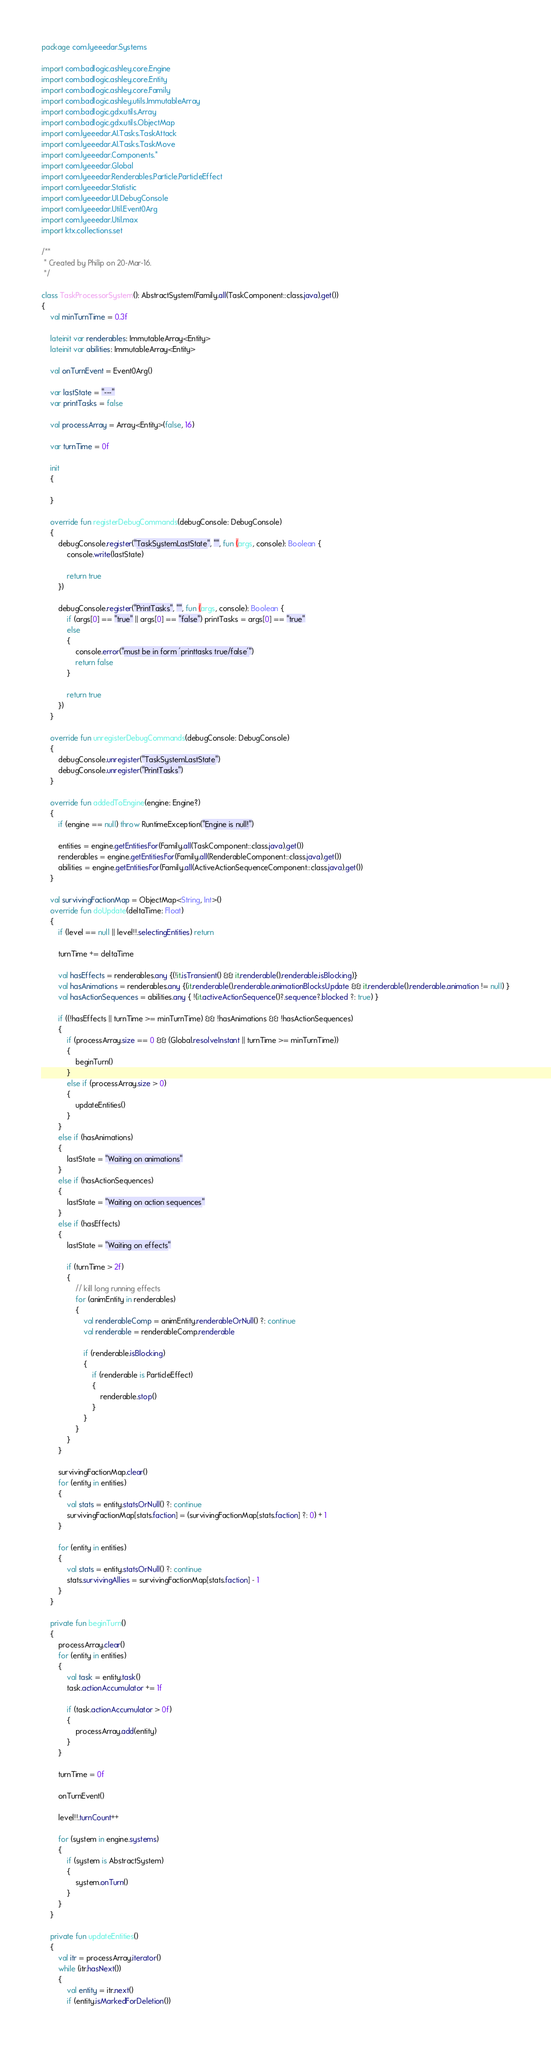<code> <loc_0><loc_0><loc_500><loc_500><_Kotlin_>package com.lyeeedar.Systems

import com.badlogic.ashley.core.Engine
import com.badlogic.ashley.core.Entity
import com.badlogic.ashley.core.Family
import com.badlogic.ashley.utils.ImmutableArray
import com.badlogic.gdx.utils.Array
import com.badlogic.gdx.utils.ObjectMap
import com.lyeeedar.AI.Tasks.TaskAttack
import com.lyeeedar.AI.Tasks.TaskMove
import com.lyeeedar.Components.*
import com.lyeeedar.Global
import com.lyeeedar.Renderables.Particle.ParticleEffect
import com.lyeeedar.Statistic
import com.lyeeedar.UI.DebugConsole
import com.lyeeedar.Util.Event0Arg
import com.lyeeedar.Util.max
import ktx.collections.set

/**
 * Created by Philip on 20-Mar-16.
 */

class TaskProcessorSystem(): AbstractSystem(Family.all(TaskComponent::class.java).get())
{
	val minTurnTime = 0.3f

	lateinit var renderables: ImmutableArray<Entity>
	lateinit var abilities: ImmutableArray<Entity>

	val onTurnEvent = Event0Arg()

	var lastState = "---"
	var printTasks = false

	val processArray = Array<Entity>(false, 16)

	var turnTime = 0f

	init
	{

	}

	override fun registerDebugCommands(debugConsole: DebugConsole)
	{
		debugConsole.register("TaskSystemLastState", "", fun (args, console): Boolean {
			console.write(lastState)

			return true
		})

		debugConsole.register("PrintTasks", "", fun (args, console): Boolean {
			if (args[0] == "true" || args[0] == "false") printTasks = args[0] == "true"
			else
			{
				console.error("must be in form 'printtasks true/false'")
				return false
			}

			return true
		})
	}

	override fun unregisterDebugCommands(debugConsole: DebugConsole)
	{
		debugConsole.unregister("TaskSystemLastState")
		debugConsole.unregister("PrintTasks")
	}

	override fun addedToEngine(engine: Engine?)
	{
		if (engine == null) throw RuntimeException("Engine is null!")

		entities = engine.getEntitiesFor(Family.all(TaskComponent::class.java).get())
		renderables = engine.getEntitiesFor(Family.all(RenderableComponent::class.java).get())
		abilities = engine.getEntitiesFor(Family.all(ActiveActionSequenceComponent::class.java).get())
	}

	val survivingFactionMap = ObjectMap<String, Int>()
	override fun doUpdate(deltaTime: Float)
	{
		if (level == null || level!!.selectingEntities) return

		turnTime += deltaTime

		val hasEffects = renderables.any {(!it.isTransient() && it.renderable().renderable.isBlocking)}
		val hasAnimations = renderables.any {(it.renderable().renderable.animationBlocksUpdate && it.renderable().renderable.animation != null) }
		val hasActionSequences = abilities.any { !(it.activeActionSequence()?.sequence?.blocked ?: true) }

		if ((!hasEffects || turnTime >= minTurnTime) && !hasAnimations && !hasActionSequences)
		{
			if (processArray.size == 0 && (Global.resolveInstant || turnTime >= minTurnTime))
			{
				beginTurn()
			}
			else if (processArray.size > 0)
			{
				updateEntities()
			}
		}
		else if (hasAnimations)
		{
			lastState = "Waiting on animations"
		}
		else if (hasActionSequences)
		{
			lastState = "Waiting on action sequences"
		}
		else if (hasEffects)
		{
			lastState = "Waiting on effects"

			if (turnTime > 2f)
			{
				// kill long running effects
				for (animEntity in renderables)
				{
					val renderableComp = animEntity.renderableOrNull() ?: continue
					val renderable = renderableComp.renderable

					if (renderable.isBlocking)
					{
						if (renderable is ParticleEffect)
						{
							renderable.stop()
						}
					}
				}
			}
		}

		survivingFactionMap.clear()
		for (entity in entities)
		{
			val stats = entity.statsOrNull() ?: continue
			survivingFactionMap[stats.faction] = (survivingFactionMap[stats.faction] ?: 0) + 1
		}

		for (entity in entities)
		{
			val stats = entity.statsOrNull() ?: continue
			stats.survivingAllies = survivingFactionMap[stats.faction] - 1
		}
	}

	private fun beginTurn()
	{
		processArray.clear()
		for (entity in entities)
		{
			val task = entity.task()
			task.actionAccumulator += 1f

			if (task.actionAccumulator > 0f)
			{
				processArray.add(entity)
			}
		}

		turnTime = 0f

		onTurnEvent()

		level!!.turnCount++

		for (system in engine.systems)
		{
			if (system is AbstractSystem)
			{
				system.onTurn()
			}
		}
	}

	private fun updateEntities()
	{
		val itr = processArray.iterator()
		while (itr.hasNext())
		{
			val entity = itr.next()
			if (entity.isMarkedForDeletion())</code> 